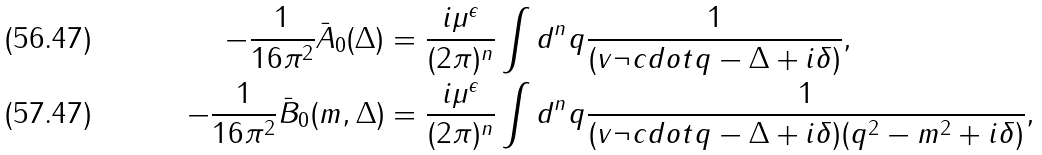Convert formula to latex. <formula><loc_0><loc_0><loc_500><loc_500>- \frac { 1 } { 1 6 \pi ^ { 2 } } \bar { A } _ { 0 } ( \Delta ) & = \frac { i \mu ^ { \epsilon } } { ( 2 \pi ) ^ { n } } \int d ^ { n } q \frac { 1 } { ( v \neg c d o t q - \Delta + i \delta ) } , \\ - \frac { 1 } { 1 6 \pi ^ { 2 } } \bar { B } _ { 0 } ( m , \Delta ) & = \frac { i \mu ^ { \epsilon } } { ( 2 \pi ) ^ { n } } \int d ^ { n } q \frac { 1 } { ( v \neg c d o t q - \Delta + i \delta ) ( q ^ { 2 } - m ^ { 2 } + i \delta ) } ,</formula> 